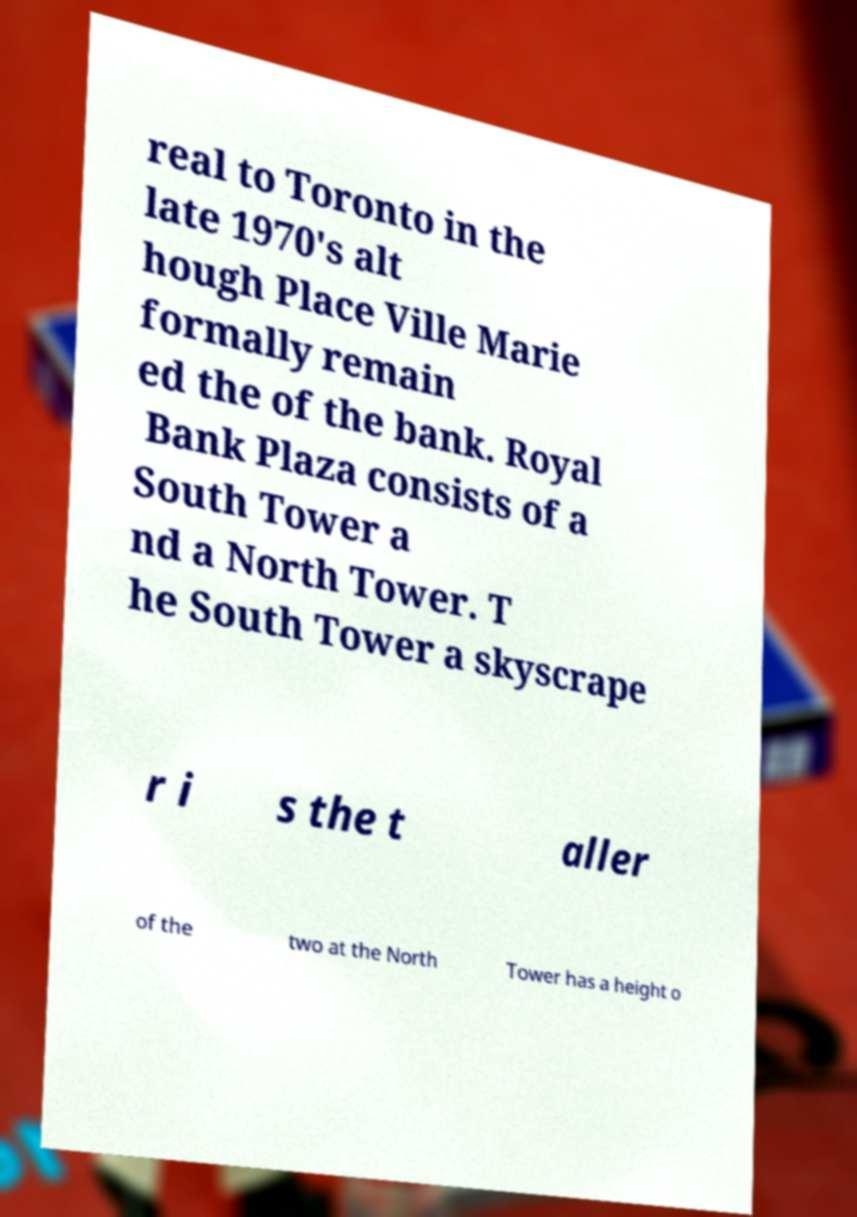Please identify and transcribe the text found in this image. real to Toronto in the late 1970's alt hough Place Ville Marie formally remain ed the of the bank. Royal Bank Plaza consists of a South Tower a nd a North Tower. T he South Tower a skyscrape r i s the t aller of the two at the North Tower has a height o 